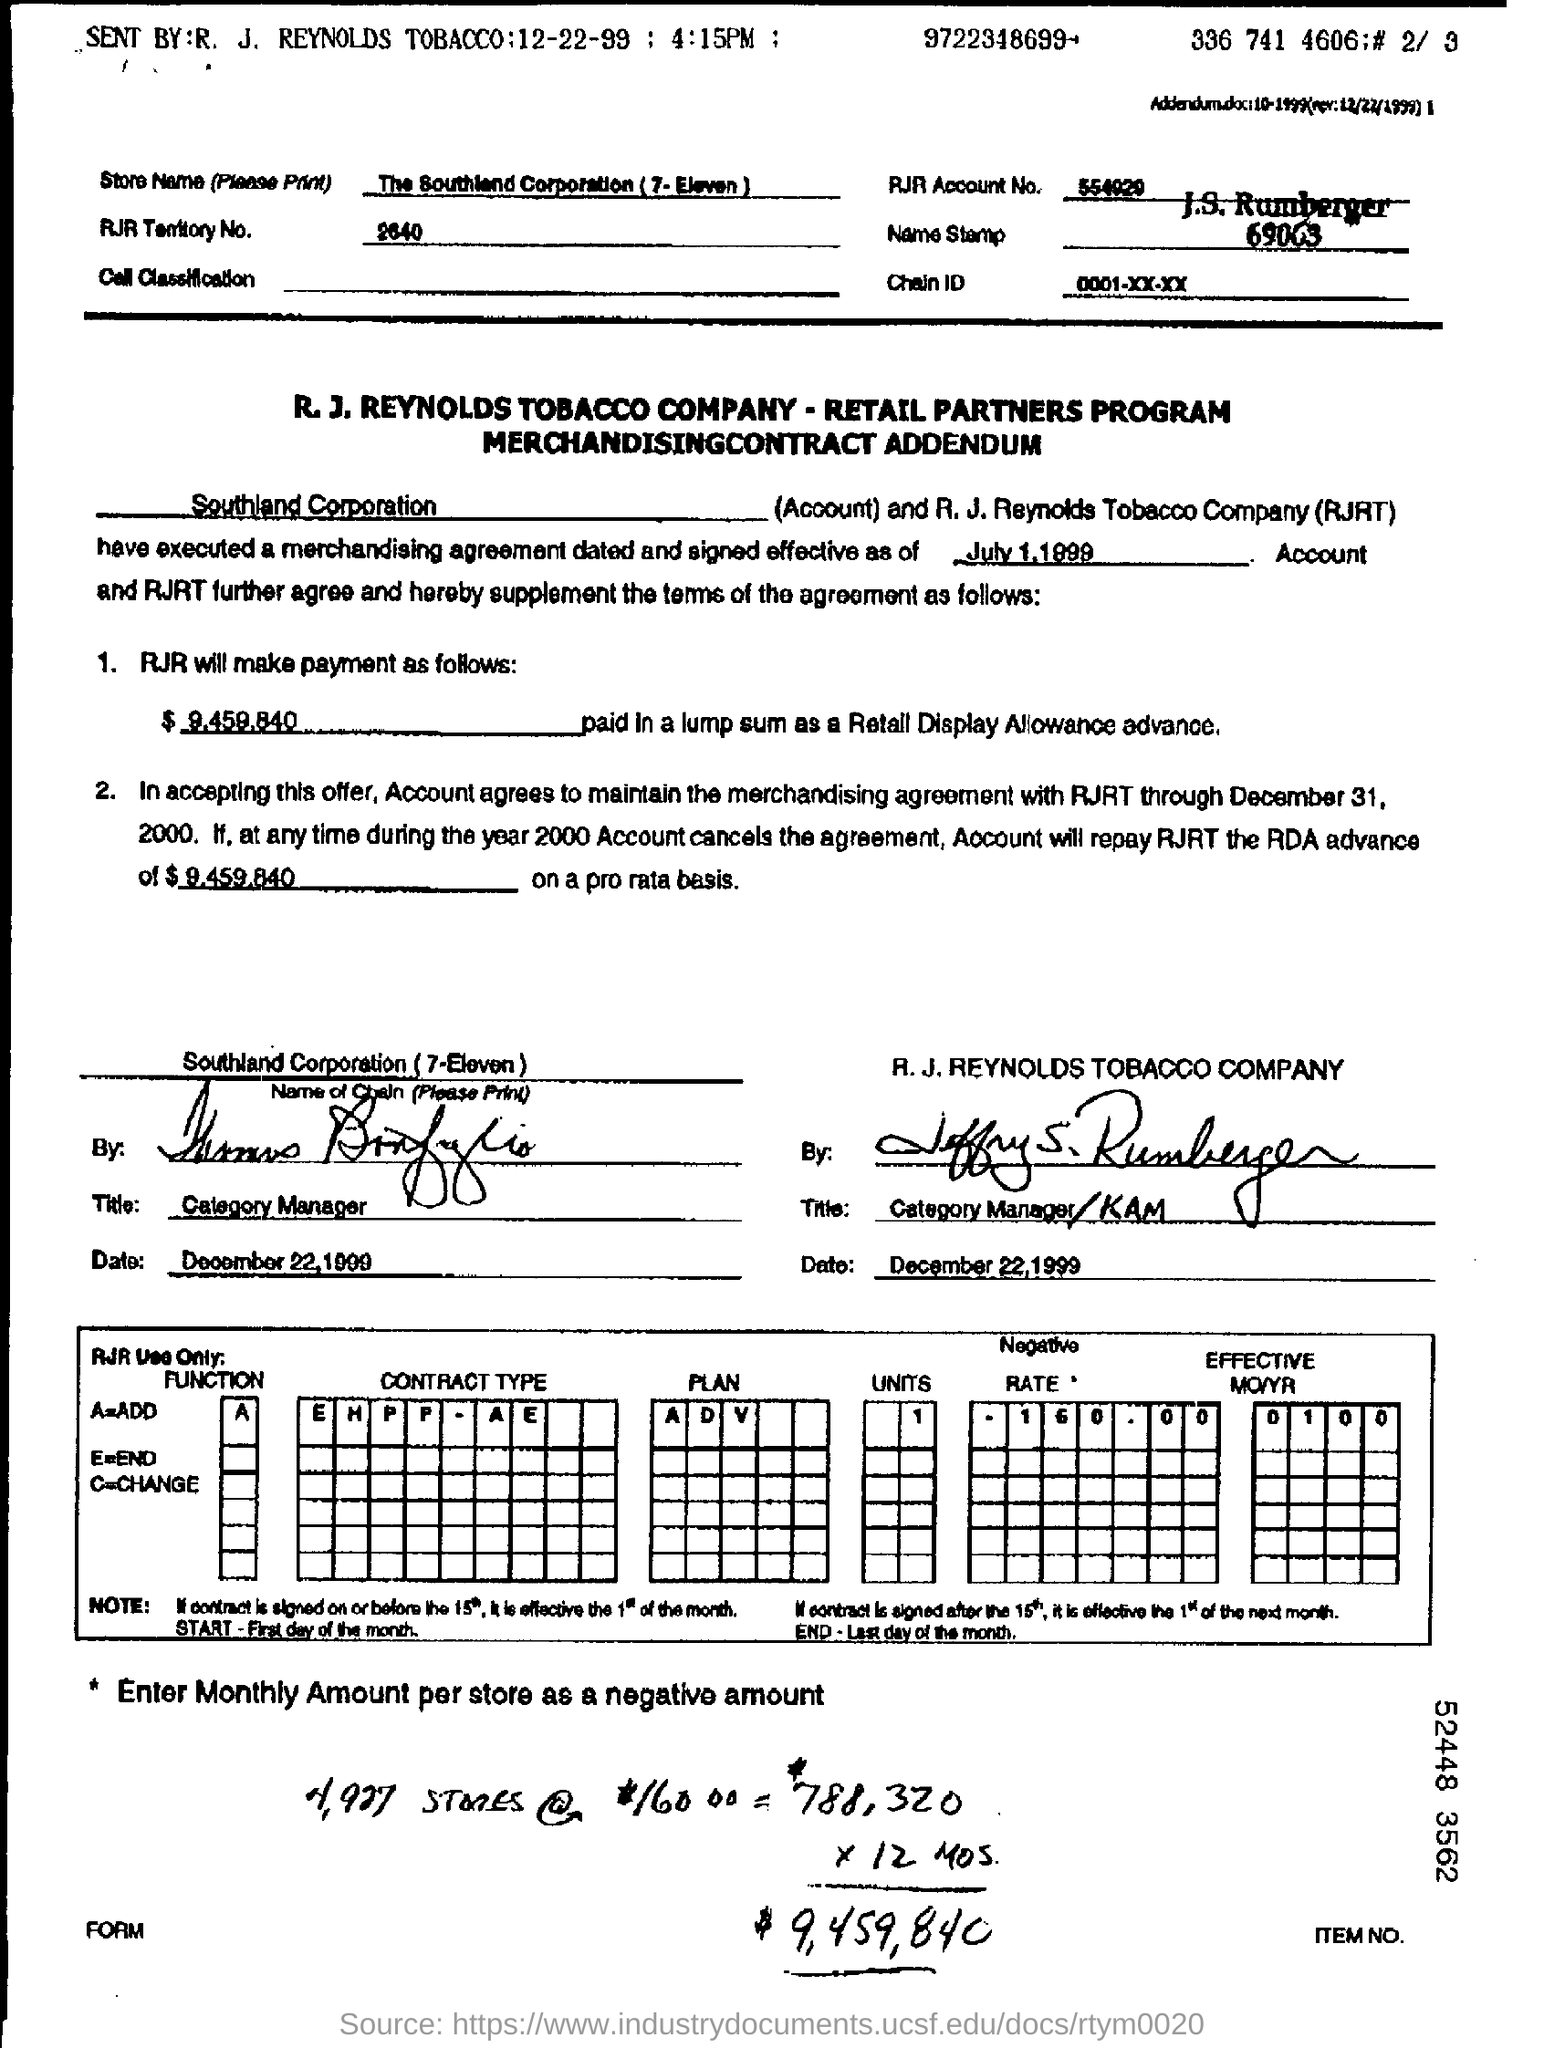What is the store name?
Your answer should be very brief. The Southland Corporation (7-eleven). What is the RJR Territory No.?
Provide a succinct answer. 2640. What is the RJR Account No.?
Keep it short and to the point. 554020. When is merchandising agreement dated and signed effective?
Offer a terse response. July 1,1999. 